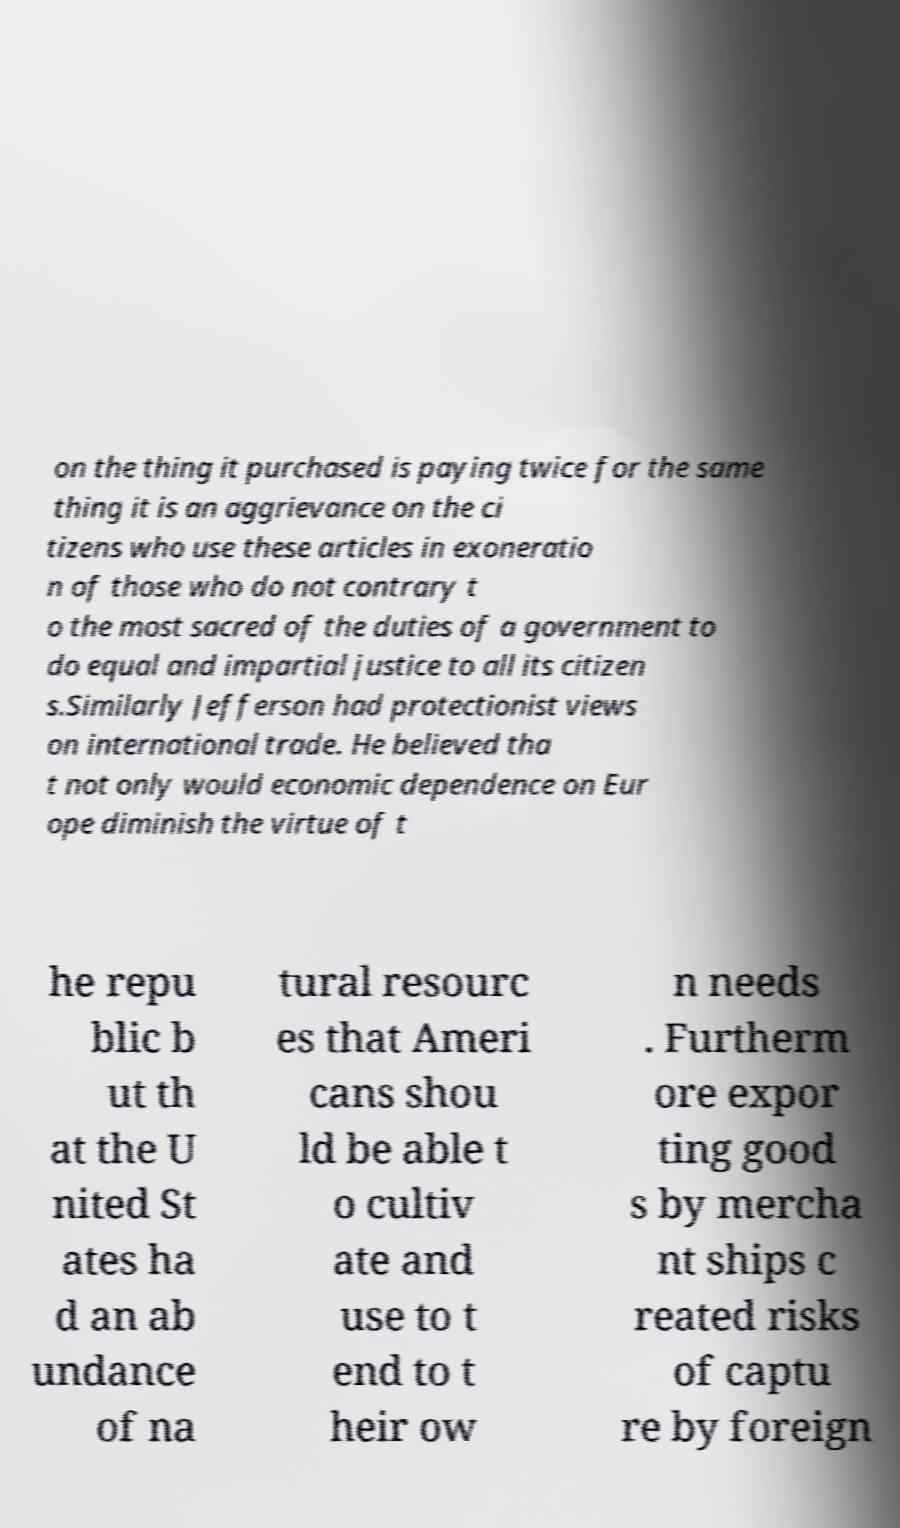I need the written content from this picture converted into text. Can you do that? on the thing it purchased is paying twice for the same thing it is an aggrievance on the ci tizens who use these articles in exoneratio n of those who do not contrary t o the most sacred of the duties of a government to do equal and impartial justice to all its citizen s.Similarly Jefferson had protectionist views on international trade. He believed tha t not only would economic dependence on Eur ope diminish the virtue of t he repu blic b ut th at the U nited St ates ha d an ab undance of na tural resourc es that Ameri cans shou ld be able t o cultiv ate and use to t end to t heir ow n needs . Furtherm ore expor ting good s by mercha nt ships c reated risks of captu re by foreign 